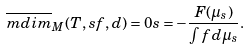<formula> <loc_0><loc_0><loc_500><loc_500>\overline { m d i m } _ { M } ( T , s f , d ) = 0 s = - \frac { F ( \mu _ { s } ) } { \int f d \mu _ { s } } .</formula> 